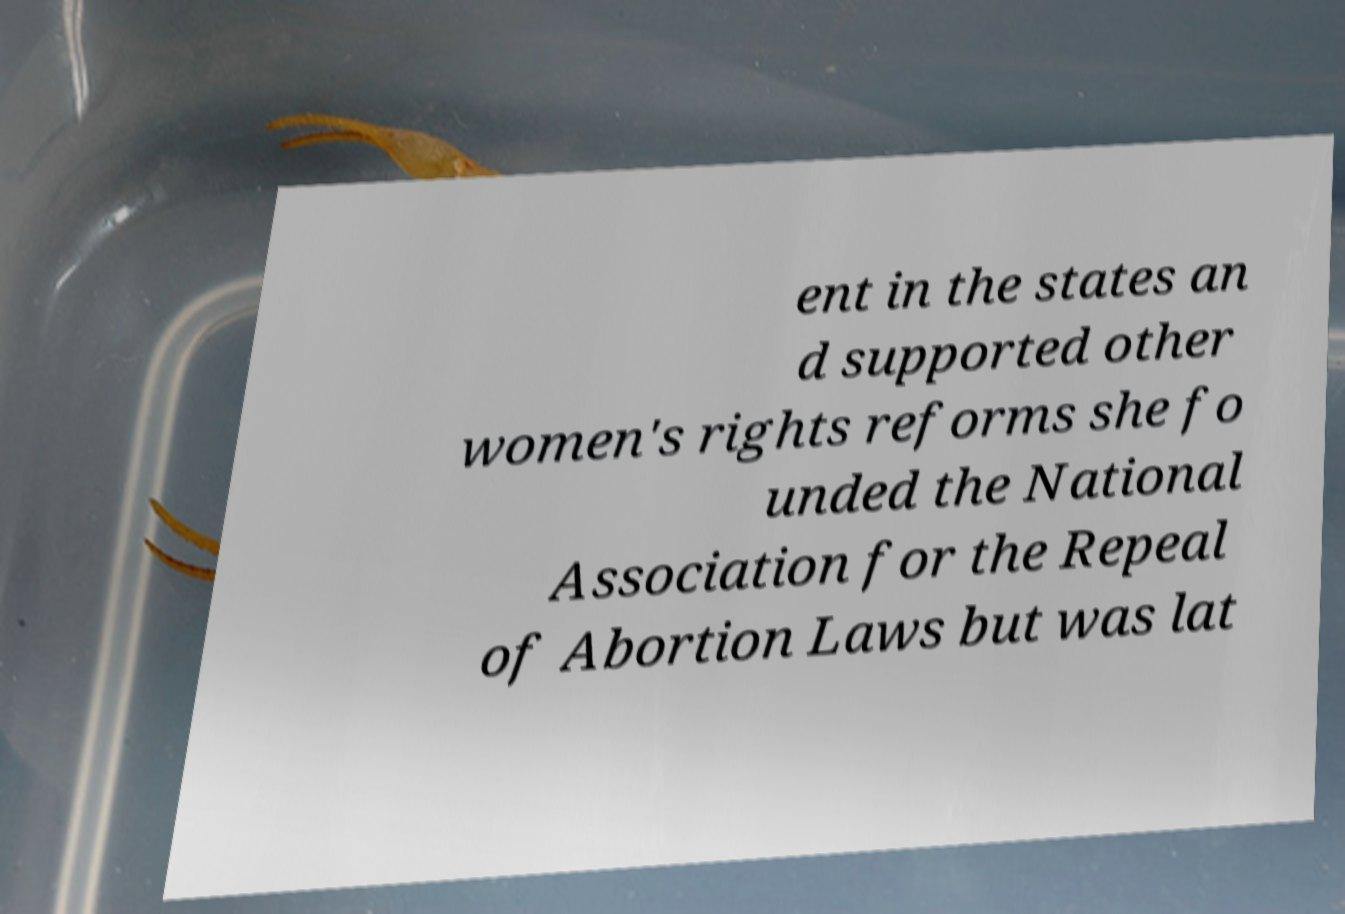What messages or text are displayed in this image? I need them in a readable, typed format. ent in the states an d supported other women's rights reforms she fo unded the National Association for the Repeal of Abortion Laws but was lat 